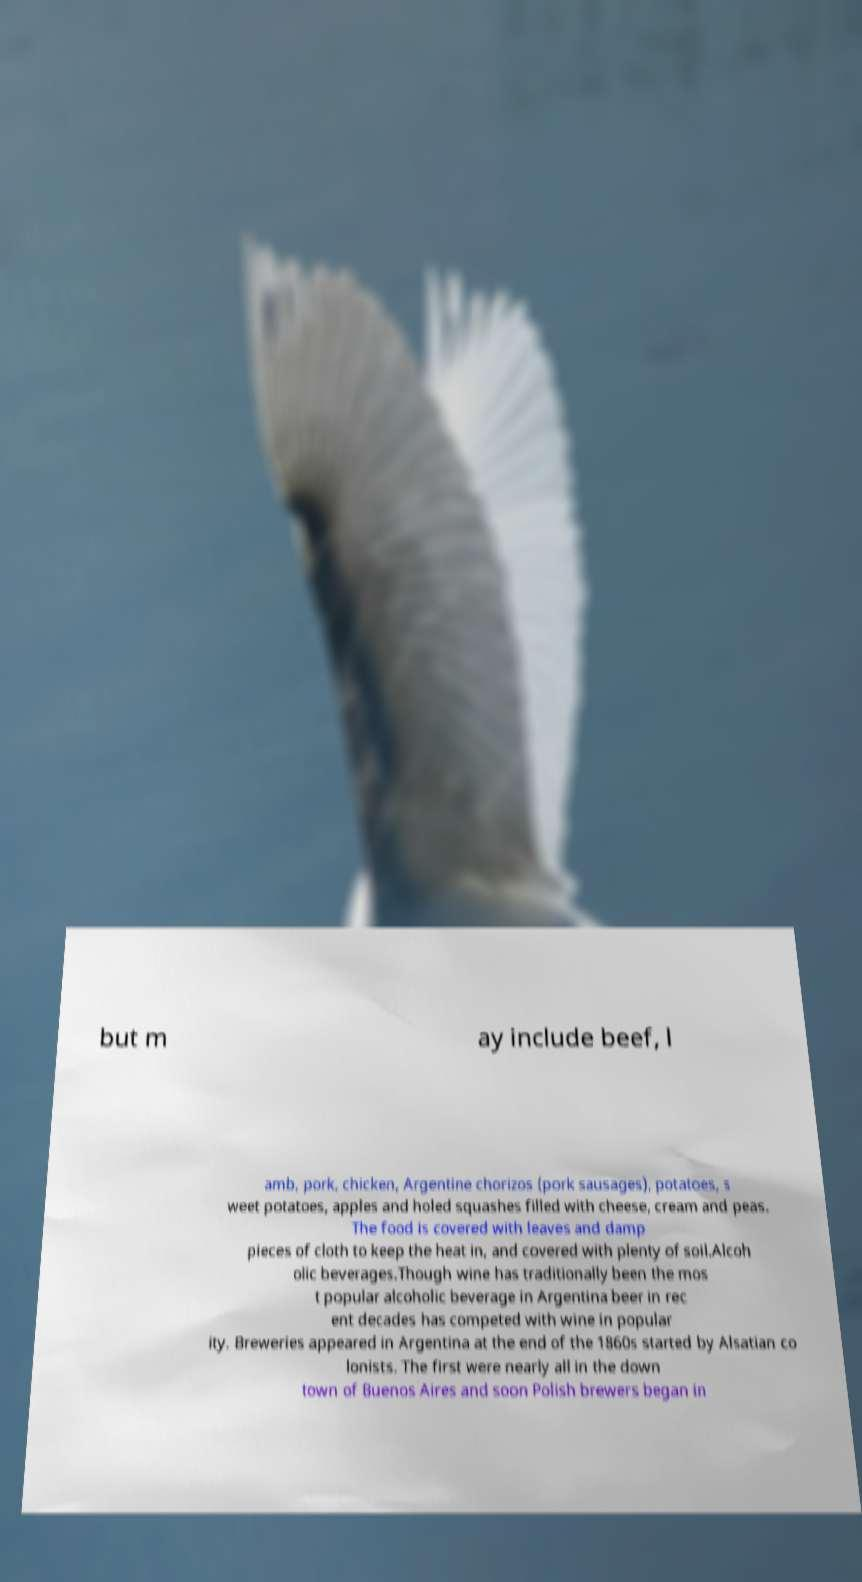Please identify and transcribe the text found in this image. but m ay include beef, l amb, pork, chicken, Argentine chorizos (pork sausages), potatoes, s weet potatoes, apples and holed squashes filled with cheese, cream and peas. The food is covered with leaves and damp pieces of cloth to keep the heat in, and covered with plenty of soil.Alcoh olic beverages.Though wine has traditionally been the mos t popular alcoholic beverage in Argentina beer in rec ent decades has competed with wine in popular ity. Breweries appeared in Argentina at the end of the 1860s started by Alsatian co lonists. The first were nearly all in the down town of Buenos Aires and soon Polish brewers began in 